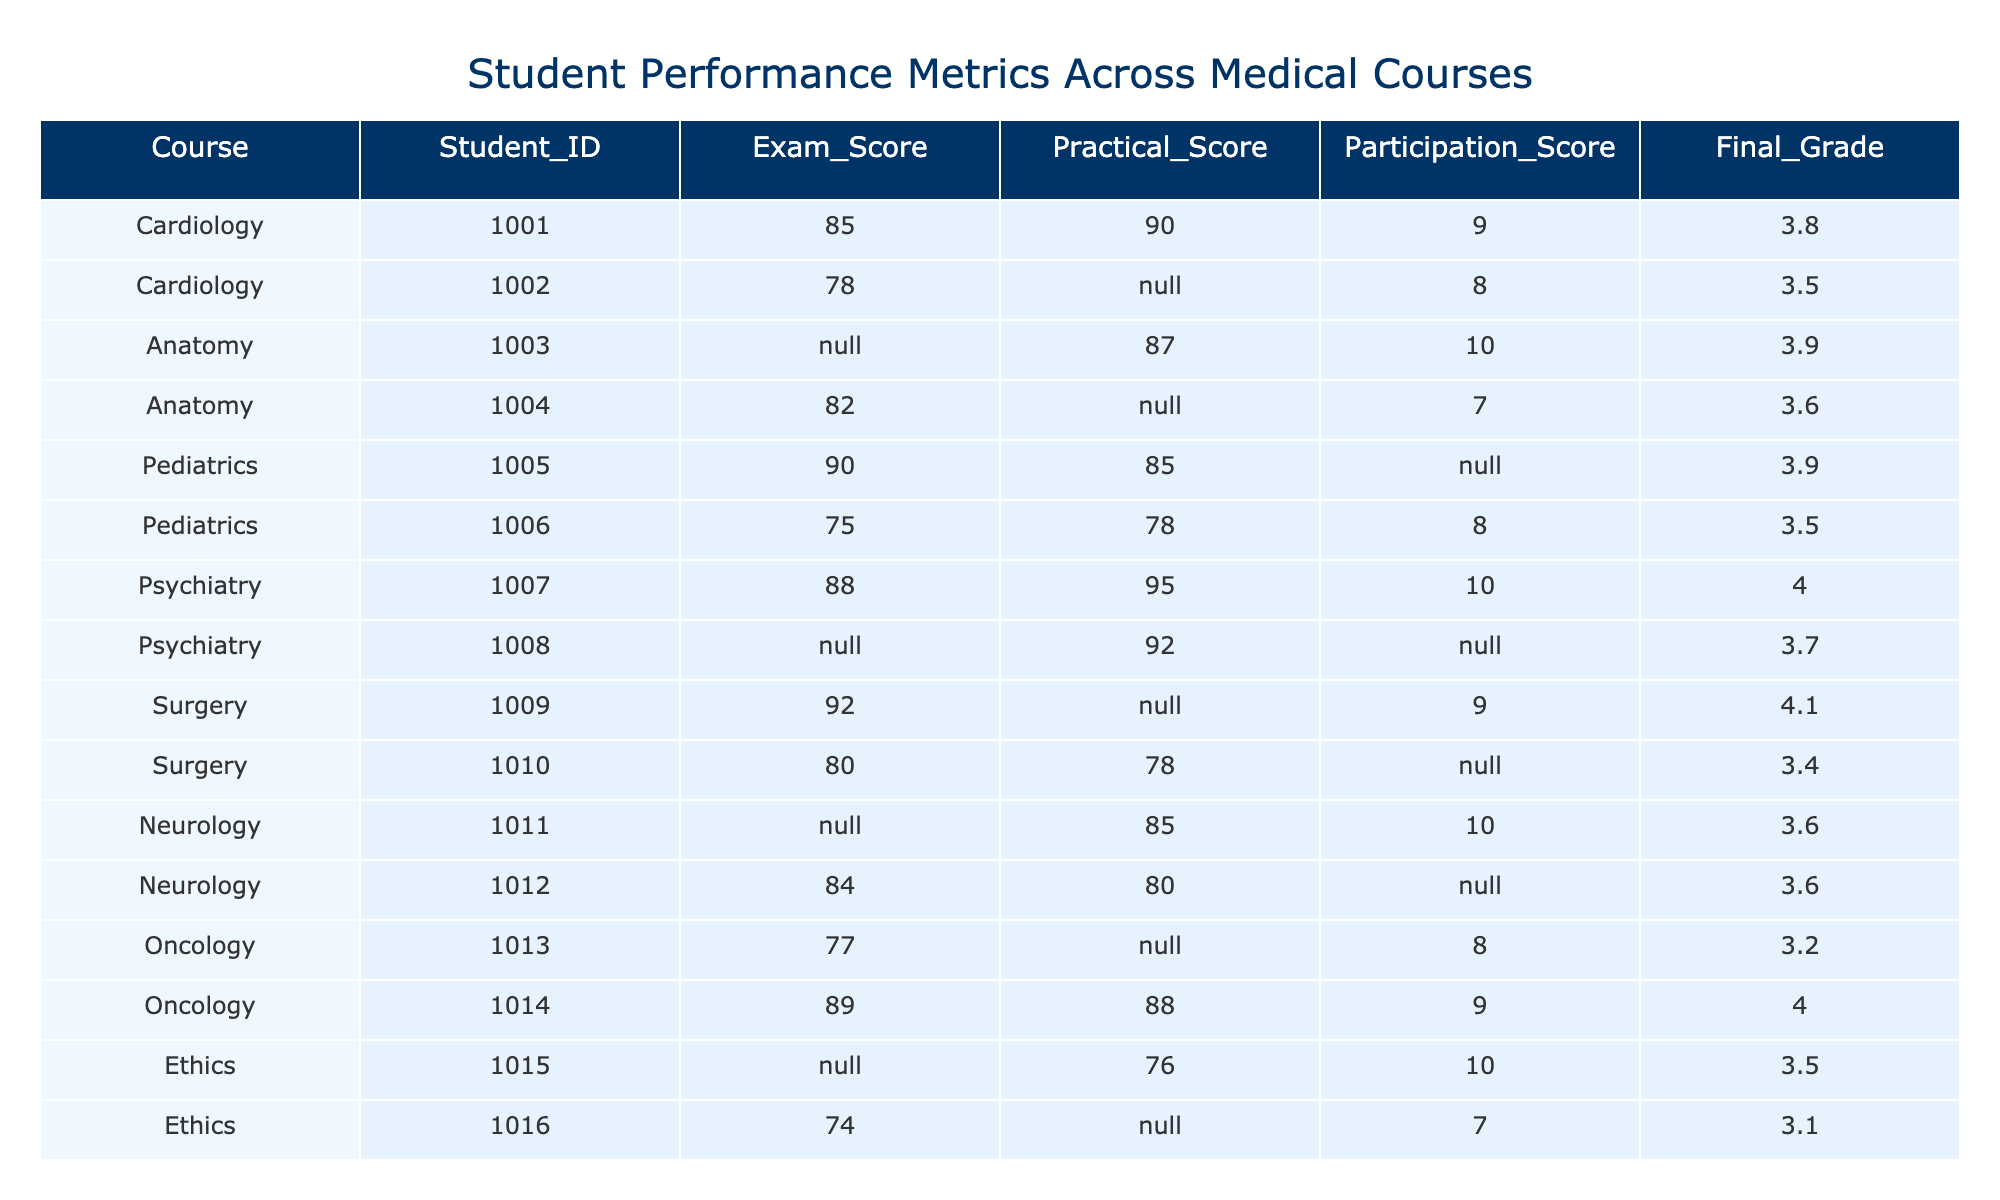What is the Final Grade of Student ID 1007? In the table, we can find the row corresponding to Student ID 1007, which is in the Psychiatry course. The Final Grade listed for this student is 4.0.
Answer: 4.0 What is the average Exam Score across all students? To find the average, sum all the Exam Scores that are not missing: (85 + 78 + 90 + 75 + 88 + 92 + 80 + 84 + 77 + 89 + 74 + 81 + 90) = 1,053. There are 13 scores, resulting in an average of 1,053/13 ≈ 81.0.
Answer: Approximately 81.0 Is there any student in the Surgery course with a Practical Score? Looking at the Surgery course data, Student ID 1009 has a Practical Score, while Student ID 1010 does not. Therefore, yes, there is at least one student in the Surgery course with a Practical Score.
Answer: Yes Which course has the highest average Final Grade? First, we calculate the average Final Grade for each course by summing the grades and dividing by the number of students in each course with grades: Cardiology (3.65), Anatomy (3.75), Pediatrics (3.7), Psychiatry (4.0), Surgery (4.25), Neurology (3.6), Oncology (3.6), Ethics (3.3), Internal Medicine (3.85). The highest average is in Surgery with an average of 4.25.
Answer: Surgery How many students participated in the Ethics course? Reviewing the Ethics course data, there are two students (Student IDs 1015 and 1016) listed under Ethics.
Answer: 2 What is the difference between the highest and lowest Exam Scores in the table? The highest Exam Score is 92 (from Student ID 1009) and the lowest is 74 (from Student ID 1016). The difference is 92 - 74 = 18.
Answer: 18 In which course did Student ID 1014 score the highest in both Practical and Final metrics? For Student ID 1014, looking at the table, the Practical Score is 88 and the Final Grade is 4.0 under Oncology. This makes it the highest combined score among applicable courses.
Answer: Oncology How many students scored below 80 in their Exam Scores? Analyzing the Exam Scores, the students with scores below 80 are Student IDs 1002 (78), 1005 (75), 1006 (75), 1010 (80), and 1013 (77). Thus, there are 4 students who scored below 80.
Answer: 4 In the Psychiatry course, what is the ratio of Practical Score to Participation Score for Student ID 1007? The Practical Score of Student ID 1007 is 95, and the Participation Score is 10. The ratio is 95:10, which simplifies to 9.5:1.
Answer: 9.5:1 Which student's Practical Score is greater than their Exam Score in the Pediatrics course? Analyzing the Pediatrics course, Student ID 1005 has an Exam Score of 90 and a Practical Score of 85, which means their Practical Score is not greater. Student ID 1006 has an Exam Score of 75 and a Practical Score of 78, which is greater.
Answer: Student ID 1006 